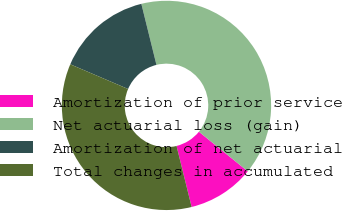Convert chart to OTSL. <chart><loc_0><loc_0><loc_500><loc_500><pie_chart><fcel>Amortization of prior service<fcel>Net actuarial loss (gain)<fcel>Amortization of net actuarial<fcel>Total changes in accumulated<nl><fcel>10.29%<fcel>39.71%<fcel>14.71%<fcel>35.29%<nl></chart> 